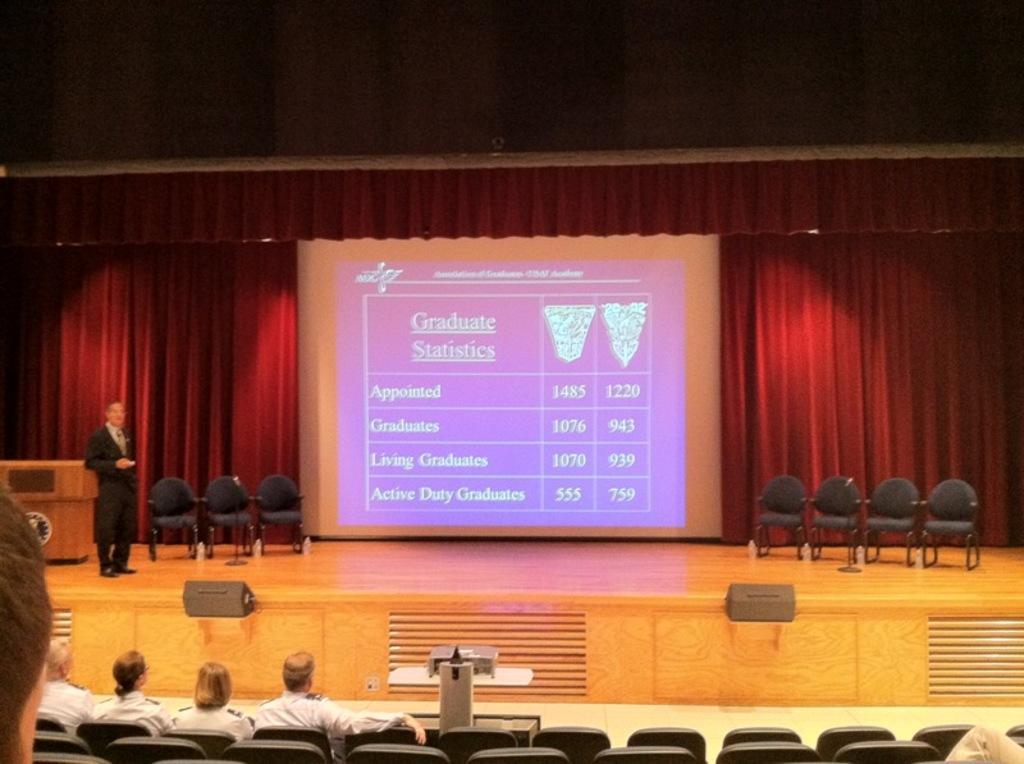In one or two sentences, can you explain what this image depicts? In this image we can see few people sitting on the chairs, a person is standing on the stage, there are few chairs, a presentation screen, a podium and black colored objects on the stage and there is a projector on the table and a curtain in the background. 